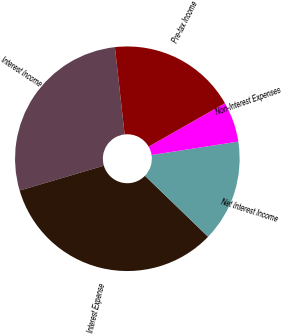Convert chart. <chart><loc_0><loc_0><loc_500><loc_500><pie_chart><fcel>Interest Income<fcel>Interest Expense<fcel>Net Interest Income<fcel>Non-Interest Expenses<fcel>Pre-tax Income<nl><fcel>27.8%<fcel>33.2%<fcel>14.67%<fcel>5.79%<fcel>18.53%<nl></chart> 